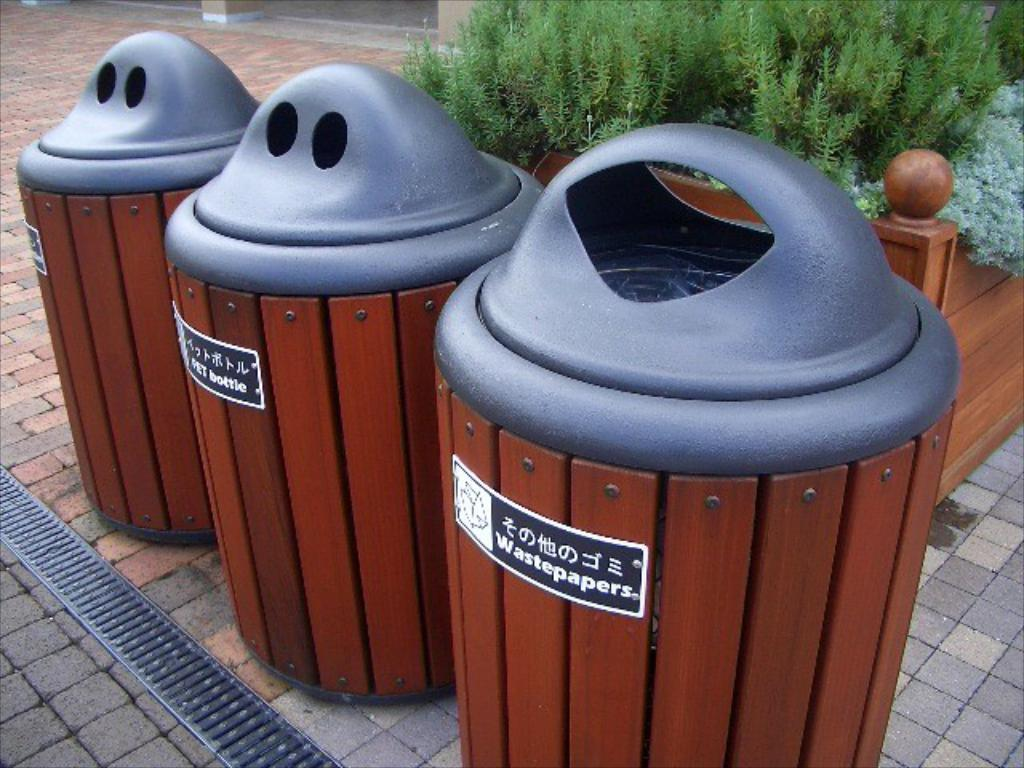<image>
Write a terse but informative summary of the picture. Bins for wastepaper and bottles and something else. 